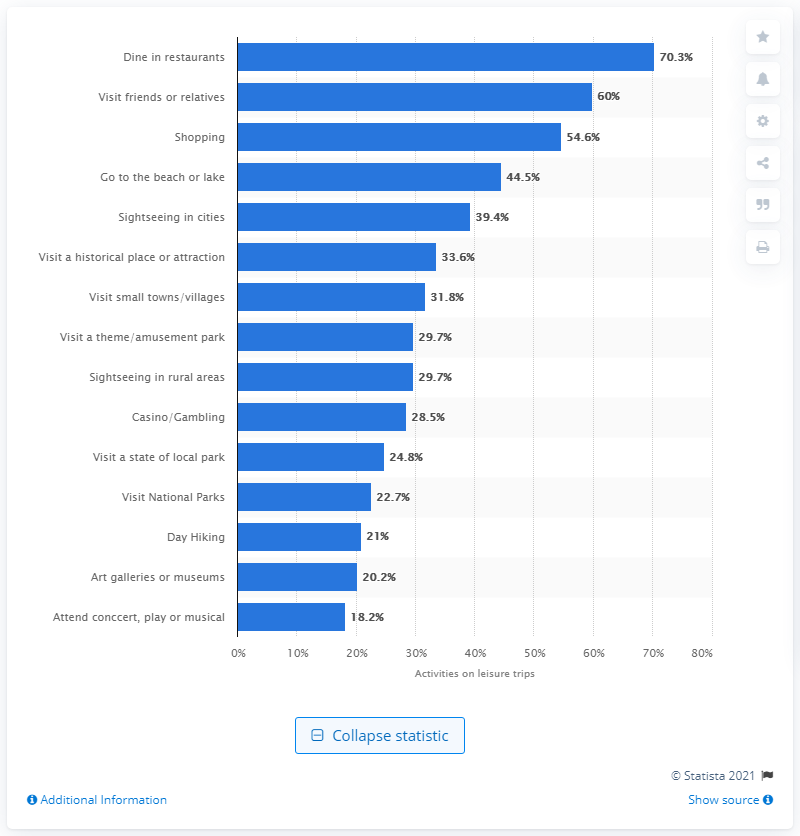Give some essential details in this illustration. In a leisure trip, 70.3% of travellers had dined at a restaurant during their trip. 